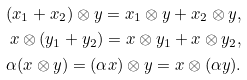<formula> <loc_0><loc_0><loc_500><loc_500>( x _ { 1 } + x _ { 2 } ) \otimes y = x _ { 1 } \otimes y + x _ { 2 } \otimes y , \\ x \otimes ( y _ { 1 } + y _ { 2 } ) = x \otimes y _ { 1 } + x \otimes y _ { 2 } , \\ \alpha ( x \otimes y ) = ( \alpha x ) \otimes y = x \otimes ( \alpha y ) .</formula> 